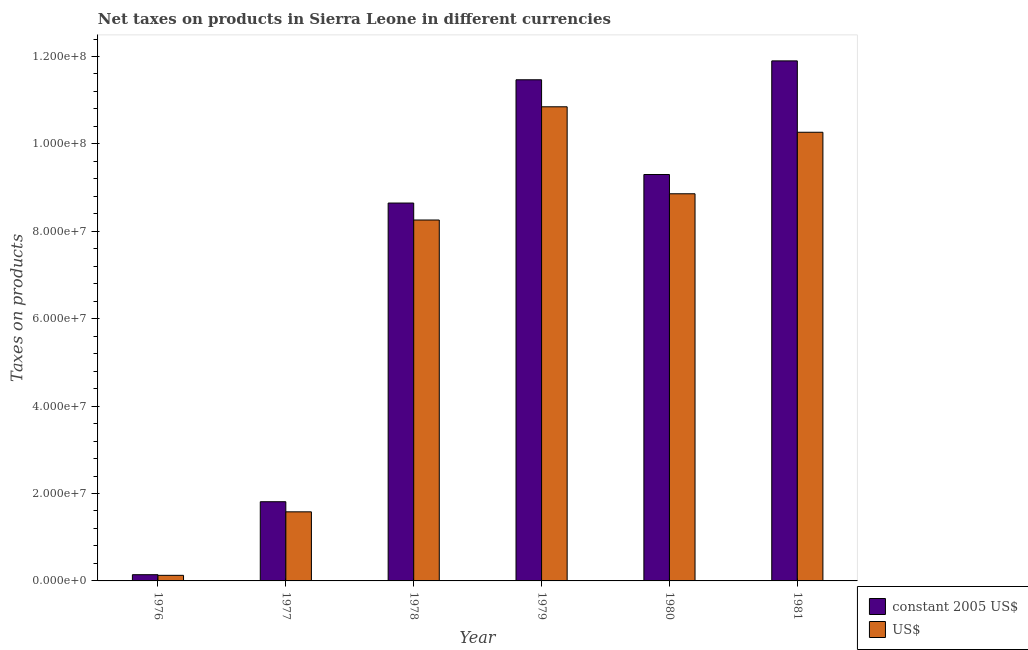How many different coloured bars are there?
Offer a very short reply. 2. How many groups of bars are there?
Offer a terse response. 6. Are the number of bars per tick equal to the number of legend labels?
Provide a succinct answer. Yes. How many bars are there on the 2nd tick from the left?
Your answer should be compact. 2. How many bars are there on the 1st tick from the right?
Ensure brevity in your answer.  2. What is the label of the 4th group of bars from the left?
Keep it short and to the point. 1979. What is the net taxes in us$ in 1978?
Give a very brief answer. 8.26e+07. Across all years, what is the maximum net taxes in us$?
Your answer should be compact. 1.08e+08. Across all years, what is the minimum net taxes in constant 2005 us$?
Keep it short and to the point. 1.42e+06. In which year was the net taxes in constant 2005 us$ minimum?
Make the answer very short. 1976. What is the total net taxes in constant 2005 us$ in the graph?
Your answer should be compact. 4.33e+08. What is the difference between the net taxes in us$ in 1976 and that in 1979?
Offer a very short reply. -1.07e+08. What is the difference between the net taxes in constant 2005 us$ in 1976 and the net taxes in us$ in 1981?
Give a very brief answer. -1.18e+08. What is the average net taxes in us$ per year?
Ensure brevity in your answer.  6.66e+07. What is the ratio of the net taxes in constant 2005 us$ in 1976 to that in 1979?
Offer a very short reply. 0.01. Is the net taxes in constant 2005 us$ in 1979 less than that in 1981?
Provide a succinct answer. Yes. What is the difference between the highest and the second highest net taxes in us$?
Give a very brief answer. 5.83e+06. What is the difference between the highest and the lowest net taxes in us$?
Offer a terse response. 1.07e+08. In how many years, is the net taxes in us$ greater than the average net taxes in us$ taken over all years?
Offer a terse response. 4. Is the sum of the net taxes in constant 2005 us$ in 1977 and 1978 greater than the maximum net taxes in us$ across all years?
Make the answer very short. No. What does the 2nd bar from the left in 1976 represents?
Your answer should be very brief. US$. What does the 1st bar from the right in 1979 represents?
Offer a very short reply. US$. Are all the bars in the graph horizontal?
Make the answer very short. No. Are the values on the major ticks of Y-axis written in scientific E-notation?
Provide a succinct answer. Yes. Does the graph contain any zero values?
Make the answer very short. No. Does the graph contain grids?
Provide a succinct answer. No. Where does the legend appear in the graph?
Your response must be concise. Bottom right. How are the legend labels stacked?
Your answer should be compact. Vertical. What is the title of the graph?
Provide a succinct answer. Net taxes on products in Sierra Leone in different currencies. Does "Start a business" appear as one of the legend labels in the graph?
Keep it short and to the point. No. What is the label or title of the X-axis?
Keep it short and to the point. Year. What is the label or title of the Y-axis?
Your answer should be compact. Taxes on products. What is the Taxes on products in constant 2005 US$ in 1976?
Provide a short and direct response. 1.42e+06. What is the Taxes on products in US$ in 1976?
Provide a succinct answer. 1.28e+06. What is the Taxes on products in constant 2005 US$ in 1977?
Provide a short and direct response. 1.81e+07. What is the Taxes on products of US$ in 1977?
Provide a short and direct response. 1.58e+07. What is the Taxes on products in constant 2005 US$ in 1978?
Your answer should be very brief. 8.65e+07. What is the Taxes on products in US$ in 1978?
Your answer should be compact. 8.26e+07. What is the Taxes on products of constant 2005 US$ in 1979?
Provide a succinct answer. 1.15e+08. What is the Taxes on products of US$ in 1979?
Offer a very short reply. 1.08e+08. What is the Taxes on products in constant 2005 US$ in 1980?
Your response must be concise. 9.30e+07. What is the Taxes on products of US$ in 1980?
Give a very brief answer. 8.86e+07. What is the Taxes on products in constant 2005 US$ in 1981?
Your answer should be compact. 1.19e+08. What is the Taxes on products of US$ in 1981?
Give a very brief answer. 1.03e+08. Across all years, what is the maximum Taxes on products of constant 2005 US$?
Make the answer very short. 1.19e+08. Across all years, what is the maximum Taxes on products in US$?
Provide a short and direct response. 1.08e+08. Across all years, what is the minimum Taxes on products of constant 2005 US$?
Make the answer very short. 1.42e+06. Across all years, what is the minimum Taxes on products of US$?
Your answer should be compact. 1.28e+06. What is the total Taxes on products in constant 2005 US$ in the graph?
Provide a succinct answer. 4.33e+08. What is the total Taxes on products in US$ in the graph?
Make the answer very short. 3.99e+08. What is the difference between the Taxes on products of constant 2005 US$ in 1976 and that in 1977?
Provide a short and direct response. -1.67e+07. What is the difference between the Taxes on products in US$ in 1976 and that in 1977?
Keep it short and to the point. -1.45e+07. What is the difference between the Taxes on products of constant 2005 US$ in 1976 and that in 1978?
Offer a terse response. -8.50e+07. What is the difference between the Taxes on products in US$ in 1976 and that in 1978?
Provide a succinct answer. -8.13e+07. What is the difference between the Taxes on products in constant 2005 US$ in 1976 and that in 1979?
Your answer should be compact. -1.13e+08. What is the difference between the Taxes on products in US$ in 1976 and that in 1979?
Offer a terse response. -1.07e+08. What is the difference between the Taxes on products in constant 2005 US$ in 1976 and that in 1980?
Give a very brief answer. -9.16e+07. What is the difference between the Taxes on products in US$ in 1976 and that in 1980?
Ensure brevity in your answer.  -8.73e+07. What is the difference between the Taxes on products in constant 2005 US$ in 1976 and that in 1981?
Your answer should be very brief. -1.18e+08. What is the difference between the Taxes on products of US$ in 1976 and that in 1981?
Ensure brevity in your answer.  -1.01e+08. What is the difference between the Taxes on products in constant 2005 US$ in 1977 and that in 1978?
Your answer should be very brief. -6.83e+07. What is the difference between the Taxes on products in US$ in 1977 and that in 1978?
Keep it short and to the point. -6.68e+07. What is the difference between the Taxes on products in constant 2005 US$ in 1977 and that in 1979?
Provide a short and direct response. -9.66e+07. What is the difference between the Taxes on products in US$ in 1977 and that in 1979?
Offer a very short reply. -9.27e+07. What is the difference between the Taxes on products of constant 2005 US$ in 1977 and that in 1980?
Your answer should be very brief. -7.49e+07. What is the difference between the Taxes on products in US$ in 1977 and that in 1980?
Provide a short and direct response. -7.28e+07. What is the difference between the Taxes on products in constant 2005 US$ in 1977 and that in 1981?
Give a very brief answer. -1.01e+08. What is the difference between the Taxes on products of US$ in 1977 and that in 1981?
Offer a very short reply. -8.69e+07. What is the difference between the Taxes on products in constant 2005 US$ in 1978 and that in 1979?
Your answer should be compact. -2.82e+07. What is the difference between the Taxes on products in US$ in 1978 and that in 1979?
Offer a very short reply. -2.59e+07. What is the difference between the Taxes on products of constant 2005 US$ in 1978 and that in 1980?
Your answer should be very brief. -6.53e+06. What is the difference between the Taxes on products in US$ in 1978 and that in 1980?
Provide a succinct answer. -6.00e+06. What is the difference between the Taxes on products of constant 2005 US$ in 1978 and that in 1981?
Provide a short and direct response. -3.25e+07. What is the difference between the Taxes on products in US$ in 1978 and that in 1981?
Your response must be concise. -2.01e+07. What is the difference between the Taxes on products in constant 2005 US$ in 1979 and that in 1980?
Ensure brevity in your answer.  2.17e+07. What is the difference between the Taxes on products of US$ in 1979 and that in 1980?
Your response must be concise. 1.99e+07. What is the difference between the Taxes on products of constant 2005 US$ in 1979 and that in 1981?
Your answer should be compact. -4.32e+06. What is the difference between the Taxes on products of US$ in 1979 and that in 1981?
Keep it short and to the point. 5.83e+06. What is the difference between the Taxes on products of constant 2005 US$ in 1980 and that in 1981?
Make the answer very short. -2.60e+07. What is the difference between the Taxes on products in US$ in 1980 and that in 1981?
Ensure brevity in your answer.  -1.41e+07. What is the difference between the Taxes on products of constant 2005 US$ in 1976 and the Taxes on products of US$ in 1977?
Give a very brief answer. -1.44e+07. What is the difference between the Taxes on products of constant 2005 US$ in 1976 and the Taxes on products of US$ in 1978?
Your answer should be very brief. -8.12e+07. What is the difference between the Taxes on products in constant 2005 US$ in 1976 and the Taxes on products in US$ in 1979?
Provide a short and direct response. -1.07e+08. What is the difference between the Taxes on products in constant 2005 US$ in 1976 and the Taxes on products in US$ in 1980?
Your response must be concise. -8.72e+07. What is the difference between the Taxes on products of constant 2005 US$ in 1976 and the Taxes on products of US$ in 1981?
Make the answer very short. -1.01e+08. What is the difference between the Taxes on products of constant 2005 US$ in 1977 and the Taxes on products of US$ in 1978?
Offer a terse response. -6.45e+07. What is the difference between the Taxes on products of constant 2005 US$ in 1977 and the Taxes on products of US$ in 1979?
Your answer should be very brief. -9.04e+07. What is the difference between the Taxes on products in constant 2005 US$ in 1977 and the Taxes on products in US$ in 1980?
Provide a short and direct response. -7.05e+07. What is the difference between the Taxes on products in constant 2005 US$ in 1977 and the Taxes on products in US$ in 1981?
Provide a succinct answer. -8.45e+07. What is the difference between the Taxes on products in constant 2005 US$ in 1978 and the Taxes on products in US$ in 1979?
Provide a succinct answer. -2.20e+07. What is the difference between the Taxes on products of constant 2005 US$ in 1978 and the Taxes on products of US$ in 1980?
Your answer should be compact. -2.12e+06. What is the difference between the Taxes on products in constant 2005 US$ in 1978 and the Taxes on products in US$ in 1981?
Your answer should be very brief. -1.62e+07. What is the difference between the Taxes on products of constant 2005 US$ in 1979 and the Taxes on products of US$ in 1980?
Give a very brief answer. 2.61e+07. What is the difference between the Taxes on products in constant 2005 US$ in 1979 and the Taxes on products in US$ in 1981?
Your answer should be very brief. 1.20e+07. What is the difference between the Taxes on products of constant 2005 US$ in 1980 and the Taxes on products of US$ in 1981?
Ensure brevity in your answer.  -9.67e+06. What is the average Taxes on products in constant 2005 US$ per year?
Make the answer very short. 7.21e+07. What is the average Taxes on products in US$ per year?
Keep it short and to the point. 6.66e+07. In the year 1976, what is the difference between the Taxes on products in constant 2005 US$ and Taxes on products in US$?
Provide a succinct answer. 1.44e+05. In the year 1977, what is the difference between the Taxes on products in constant 2005 US$ and Taxes on products in US$?
Keep it short and to the point. 2.32e+06. In the year 1978, what is the difference between the Taxes on products of constant 2005 US$ and Taxes on products of US$?
Ensure brevity in your answer.  3.88e+06. In the year 1979, what is the difference between the Taxes on products of constant 2005 US$ and Taxes on products of US$?
Offer a very short reply. 6.18e+06. In the year 1980, what is the difference between the Taxes on products in constant 2005 US$ and Taxes on products in US$?
Offer a very short reply. 4.41e+06. In the year 1981, what is the difference between the Taxes on products in constant 2005 US$ and Taxes on products in US$?
Provide a succinct answer. 1.63e+07. What is the ratio of the Taxes on products of constant 2005 US$ in 1976 to that in 1977?
Your answer should be very brief. 0.08. What is the ratio of the Taxes on products of US$ in 1976 to that in 1977?
Your answer should be very brief. 0.08. What is the ratio of the Taxes on products of constant 2005 US$ in 1976 to that in 1978?
Provide a short and direct response. 0.02. What is the ratio of the Taxes on products in US$ in 1976 to that in 1978?
Ensure brevity in your answer.  0.02. What is the ratio of the Taxes on products of constant 2005 US$ in 1976 to that in 1979?
Your answer should be very brief. 0.01. What is the ratio of the Taxes on products of US$ in 1976 to that in 1979?
Ensure brevity in your answer.  0.01. What is the ratio of the Taxes on products in constant 2005 US$ in 1976 to that in 1980?
Keep it short and to the point. 0.02. What is the ratio of the Taxes on products of US$ in 1976 to that in 1980?
Provide a short and direct response. 0.01. What is the ratio of the Taxes on products in constant 2005 US$ in 1976 to that in 1981?
Offer a very short reply. 0.01. What is the ratio of the Taxes on products of US$ in 1976 to that in 1981?
Offer a very short reply. 0.01. What is the ratio of the Taxes on products in constant 2005 US$ in 1977 to that in 1978?
Give a very brief answer. 0.21. What is the ratio of the Taxes on products in US$ in 1977 to that in 1978?
Keep it short and to the point. 0.19. What is the ratio of the Taxes on products in constant 2005 US$ in 1977 to that in 1979?
Ensure brevity in your answer.  0.16. What is the ratio of the Taxes on products of US$ in 1977 to that in 1979?
Your answer should be very brief. 0.15. What is the ratio of the Taxes on products of constant 2005 US$ in 1977 to that in 1980?
Provide a short and direct response. 0.19. What is the ratio of the Taxes on products of US$ in 1977 to that in 1980?
Provide a short and direct response. 0.18. What is the ratio of the Taxes on products of constant 2005 US$ in 1977 to that in 1981?
Your answer should be compact. 0.15. What is the ratio of the Taxes on products of US$ in 1977 to that in 1981?
Ensure brevity in your answer.  0.15. What is the ratio of the Taxes on products in constant 2005 US$ in 1978 to that in 1979?
Your answer should be compact. 0.75. What is the ratio of the Taxes on products of US$ in 1978 to that in 1979?
Give a very brief answer. 0.76. What is the ratio of the Taxes on products in constant 2005 US$ in 1978 to that in 1980?
Make the answer very short. 0.93. What is the ratio of the Taxes on products of US$ in 1978 to that in 1980?
Ensure brevity in your answer.  0.93. What is the ratio of the Taxes on products of constant 2005 US$ in 1978 to that in 1981?
Your response must be concise. 0.73. What is the ratio of the Taxes on products in US$ in 1978 to that in 1981?
Ensure brevity in your answer.  0.8. What is the ratio of the Taxes on products of constant 2005 US$ in 1979 to that in 1980?
Make the answer very short. 1.23. What is the ratio of the Taxes on products of US$ in 1979 to that in 1980?
Offer a very short reply. 1.22. What is the ratio of the Taxes on products in constant 2005 US$ in 1979 to that in 1981?
Give a very brief answer. 0.96. What is the ratio of the Taxes on products of US$ in 1979 to that in 1981?
Your answer should be very brief. 1.06. What is the ratio of the Taxes on products of constant 2005 US$ in 1980 to that in 1981?
Offer a terse response. 0.78. What is the ratio of the Taxes on products in US$ in 1980 to that in 1981?
Provide a short and direct response. 0.86. What is the difference between the highest and the second highest Taxes on products in constant 2005 US$?
Your answer should be compact. 4.32e+06. What is the difference between the highest and the second highest Taxes on products in US$?
Ensure brevity in your answer.  5.83e+06. What is the difference between the highest and the lowest Taxes on products of constant 2005 US$?
Make the answer very short. 1.18e+08. What is the difference between the highest and the lowest Taxes on products in US$?
Your answer should be very brief. 1.07e+08. 